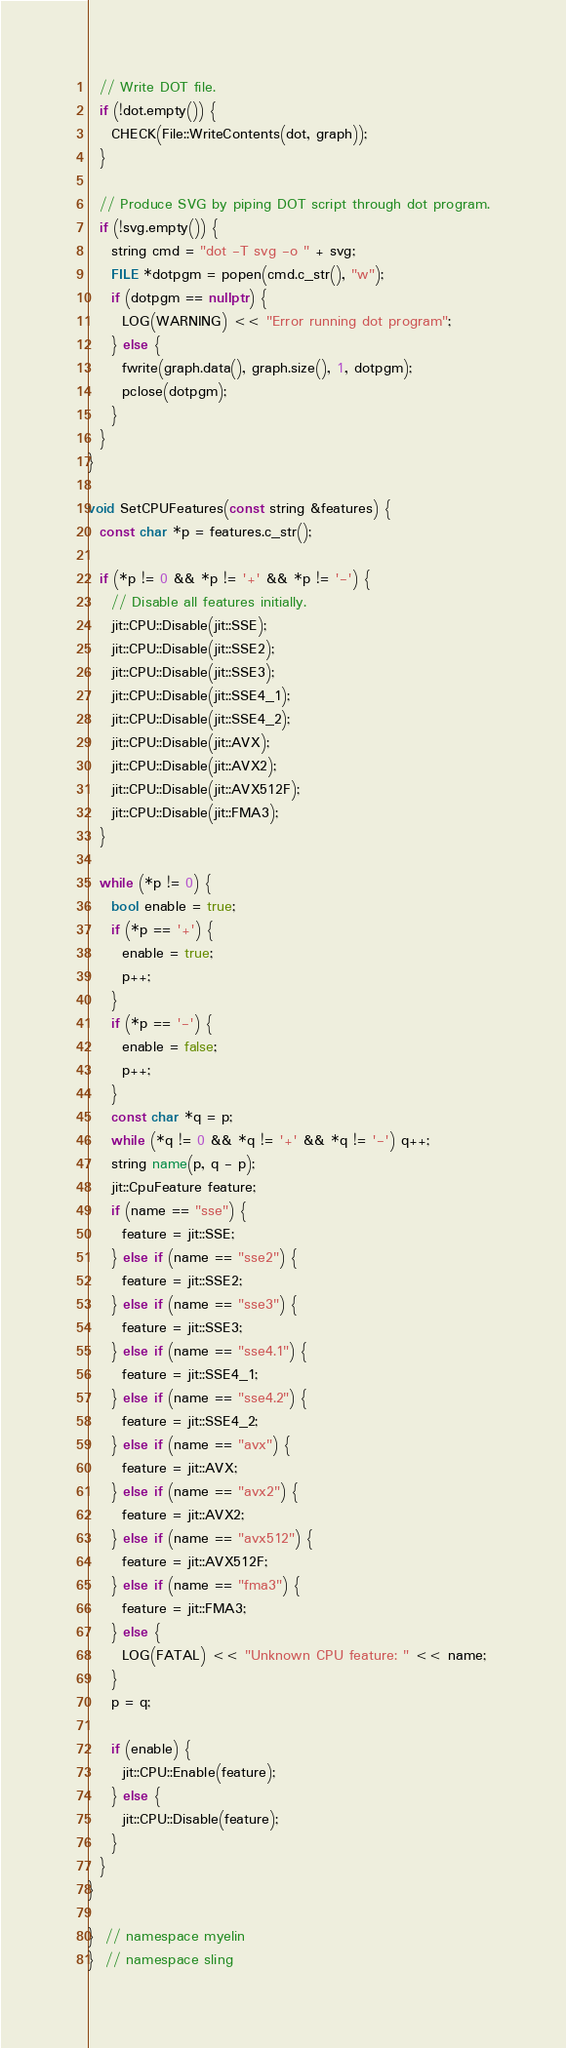<code> <loc_0><loc_0><loc_500><loc_500><_C++_>
  // Write DOT file.
  if (!dot.empty()) {
    CHECK(File::WriteContents(dot, graph));
  }

  // Produce SVG by piping DOT script through dot program.
  if (!svg.empty()) {
    string cmd = "dot -T svg -o " + svg;
    FILE *dotpgm = popen(cmd.c_str(), "w");
    if (dotpgm == nullptr) {
      LOG(WARNING) << "Error running dot program";
    } else {
      fwrite(graph.data(), graph.size(), 1, dotpgm);
      pclose(dotpgm);
    }
  }
}

void SetCPUFeatures(const string &features) {
  const char *p = features.c_str();

  if (*p != 0 && *p != '+' && *p != '-') {
    // Disable all features initially.
    jit::CPU::Disable(jit::SSE);
    jit::CPU::Disable(jit::SSE2);
    jit::CPU::Disable(jit::SSE3);
    jit::CPU::Disable(jit::SSE4_1);
    jit::CPU::Disable(jit::SSE4_2);
    jit::CPU::Disable(jit::AVX);
    jit::CPU::Disable(jit::AVX2);
    jit::CPU::Disable(jit::AVX512F);
    jit::CPU::Disable(jit::FMA3);
  }

  while (*p != 0) {
    bool enable = true;
    if (*p == '+') {
      enable = true;
      p++;
    }
    if (*p == '-') {
      enable = false;
      p++;
    }
    const char *q = p;
    while (*q != 0 && *q != '+' && *q != '-') q++;
    string name(p, q - p);
    jit::CpuFeature feature;
    if (name == "sse") {
      feature = jit::SSE;
    } else if (name == "sse2") {
      feature = jit::SSE2;
    } else if (name == "sse3") {
      feature = jit::SSE3;
    } else if (name == "sse4.1") {
      feature = jit::SSE4_1;
    } else if (name == "sse4.2") {
      feature = jit::SSE4_2;
    } else if (name == "avx") {
      feature = jit::AVX;
    } else if (name == "avx2") {
      feature = jit::AVX2;
    } else if (name == "avx512") {
      feature = jit::AVX512F;
    } else if (name == "fma3") {
      feature = jit::FMA3;
    } else {
      LOG(FATAL) << "Unknown CPU feature: " << name;
    }
    p = q;

    if (enable) {
      jit::CPU::Enable(feature);
    } else {
      jit::CPU::Disable(feature);
    }
  }
}

}  // namespace myelin
}  // namespace sling

</code> 